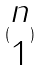<formula> <loc_0><loc_0><loc_500><loc_500>( \begin{matrix} n \\ 1 \end{matrix} )</formula> 